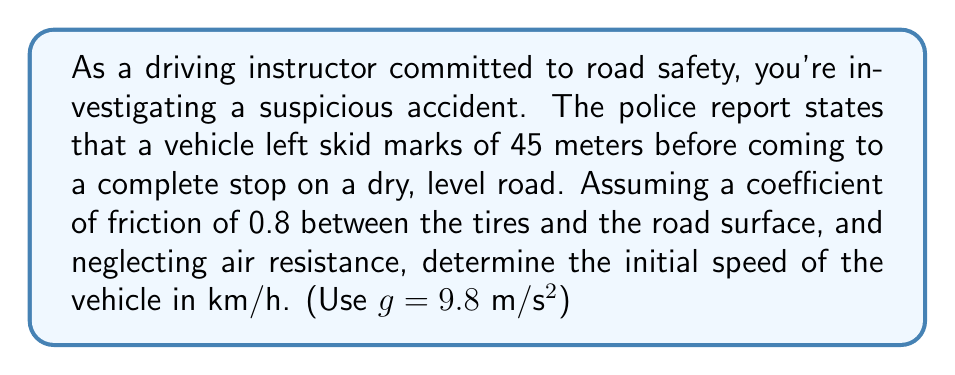What is the answer to this math problem? To solve this inverse problem, we'll use the work-energy principle and the equation for work done by friction.

Step 1: Identify the relevant equations
Work-energy principle: $W_f = \Delta KE$
Work done by friction: $W_f = F_f \cdot d$
Friction force: $F_f = \mu \cdot m \cdot g$
Kinetic energy: $KE = \frac{1}{2}mv^2$

Step 2: Set up the equation
$\mu \cdot m \cdot g \cdot d = \frac{1}{2}mv_i^2 - \frac{1}{2}mv_f^2$

Where:
$\mu$ = coefficient of friction (0.8)
$m$ = mass of the vehicle (cancels out)
$g$ = acceleration due to gravity (9.8 m/s²)
$d$ = stopping distance (45 m)
$v_i$ = initial velocity (unknown)
$v_f$ = final velocity (0 m/s)

Step 3: Simplify and solve for $v_i$
$0.8 \cdot 9.8 \cdot 45 = \frac{1}{2}v_i^2 - 0$
$352.8 = \frac{1}{2}v_i^2$
$v_i^2 = 705.6$
$v_i = \sqrt{705.6} = 26.56$ m/s

Step 4: Convert to km/h
$26.56 \frac{m}{s} \cdot \frac{3600 s}{1 h} \cdot \frac{1 km}{1000 m} = 95.62$ km/h
Answer: 95.62 km/h 